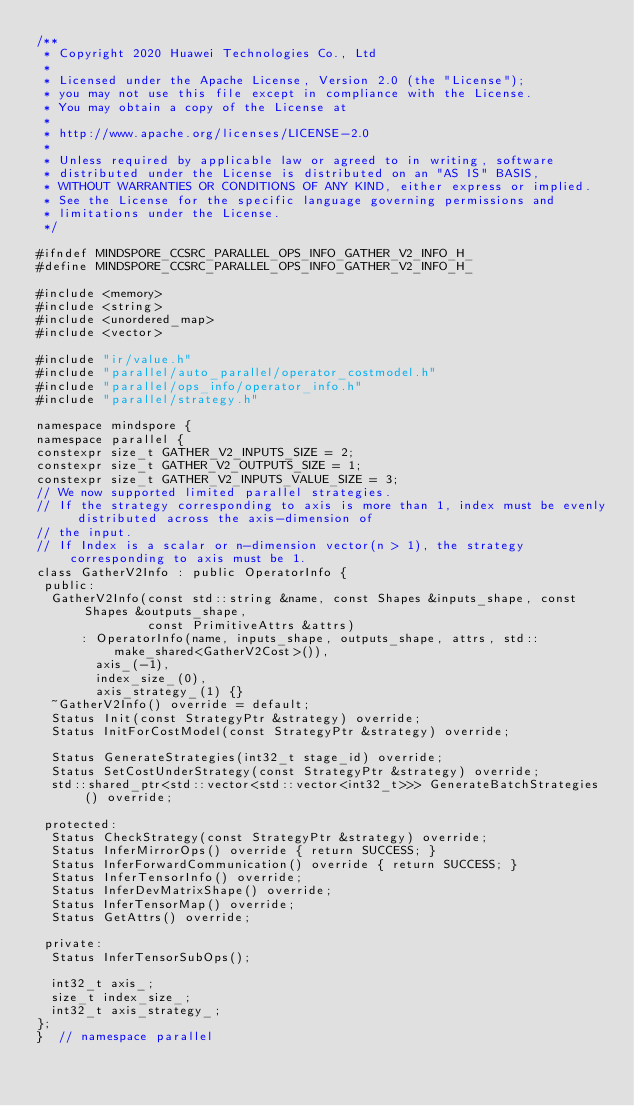<code> <loc_0><loc_0><loc_500><loc_500><_C_>/**
 * Copyright 2020 Huawei Technologies Co., Ltd
 *
 * Licensed under the Apache License, Version 2.0 (the "License");
 * you may not use this file except in compliance with the License.
 * You may obtain a copy of the License at
 *
 * http://www.apache.org/licenses/LICENSE-2.0
 *
 * Unless required by applicable law or agreed to in writing, software
 * distributed under the License is distributed on an "AS IS" BASIS,
 * WITHOUT WARRANTIES OR CONDITIONS OF ANY KIND, either express or implied.
 * See the License for the specific language governing permissions and
 * limitations under the License.
 */

#ifndef MINDSPORE_CCSRC_PARALLEL_OPS_INFO_GATHER_V2_INFO_H_
#define MINDSPORE_CCSRC_PARALLEL_OPS_INFO_GATHER_V2_INFO_H_

#include <memory>
#include <string>
#include <unordered_map>
#include <vector>

#include "ir/value.h"
#include "parallel/auto_parallel/operator_costmodel.h"
#include "parallel/ops_info/operator_info.h"
#include "parallel/strategy.h"

namespace mindspore {
namespace parallel {
constexpr size_t GATHER_V2_INPUTS_SIZE = 2;
constexpr size_t GATHER_V2_OUTPUTS_SIZE = 1;
constexpr size_t GATHER_V2_INPUTS_VALUE_SIZE = 3;
// We now supported limited parallel strategies.
// If the strategy corresponding to axis is more than 1, index must be evenly distributed across the axis-dimension of
// the input.
// If Index is a scalar or n-dimension vector(n > 1), the strategy corresponding to axis must be 1.
class GatherV2Info : public OperatorInfo {
 public:
  GatherV2Info(const std::string &name, const Shapes &inputs_shape, const Shapes &outputs_shape,
               const PrimitiveAttrs &attrs)
      : OperatorInfo(name, inputs_shape, outputs_shape, attrs, std::make_shared<GatherV2Cost>()),
        axis_(-1),
        index_size_(0),
        axis_strategy_(1) {}
  ~GatherV2Info() override = default;
  Status Init(const StrategyPtr &strategy) override;
  Status InitForCostModel(const StrategyPtr &strategy) override;

  Status GenerateStrategies(int32_t stage_id) override;
  Status SetCostUnderStrategy(const StrategyPtr &strategy) override;
  std::shared_ptr<std::vector<std::vector<int32_t>>> GenerateBatchStrategies() override;

 protected:
  Status CheckStrategy(const StrategyPtr &strategy) override;
  Status InferMirrorOps() override { return SUCCESS; }
  Status InferForwardCommunication() override { return SUCCESS; }
  Status InferTensorInfo() override;
  Status InferDevMatrixShape() override;
  Status InferTensorMap() override;
  Status GetAttrs() override;

 private:
  Status InferTensorSubOps();

  int32_t axis_;
  size_t index_size_;
  int32_t axis_strategy_;
};
}  // namespace parallel</code> 